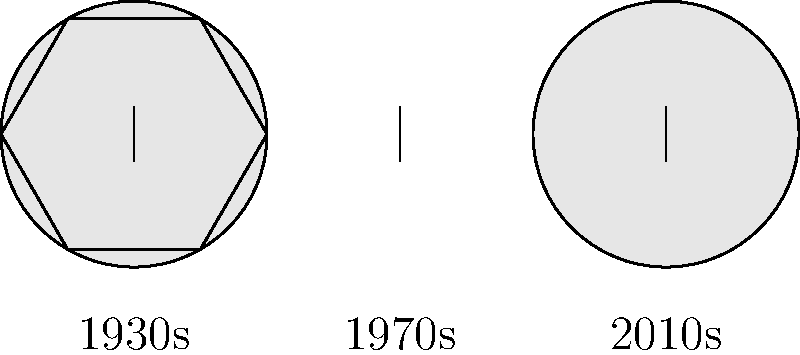Based on the diagram showing the evolution of soccer ball designs, which shape represents the most significant departure from the traditional spherical design? To answer this question, let's analyze the shapes presented in the diagram:

1. 1930s ball: This is represented by a perfect circle, indicating a traditional spherical design.

2. 1970s ball: This is shown as a hexagon, which is a significant departure from the spherical shape. It represents the iconic black and white paneled ball design introduced in the 1970 World Cup.

3. 2010s ball: This is again represented by a circle, suggesting a return to a more spherical shape, albeit with modern materials and surface textures.

The 1970s hexagonal design stands out as the most significant departure from the traditional spherical shape. This design, known as the "Telstar" ball, introduced the iconic black and white paneled look that became synonymous with soccer balls for decades.

The shift from a sphere to a polyhedron (albeit still roughly spherical when inflated) was a major innovation in soccer ball design. It improved visibility on black-and-white televisions and provided more predictable flight characteristics.

In contrast, both the 1930s and 2010s designs maintain the basic spherical shape, even though modern balls incorporate advanced materials and subtle surface textures for improved performance.
Answer: 1970s hexagonal design 